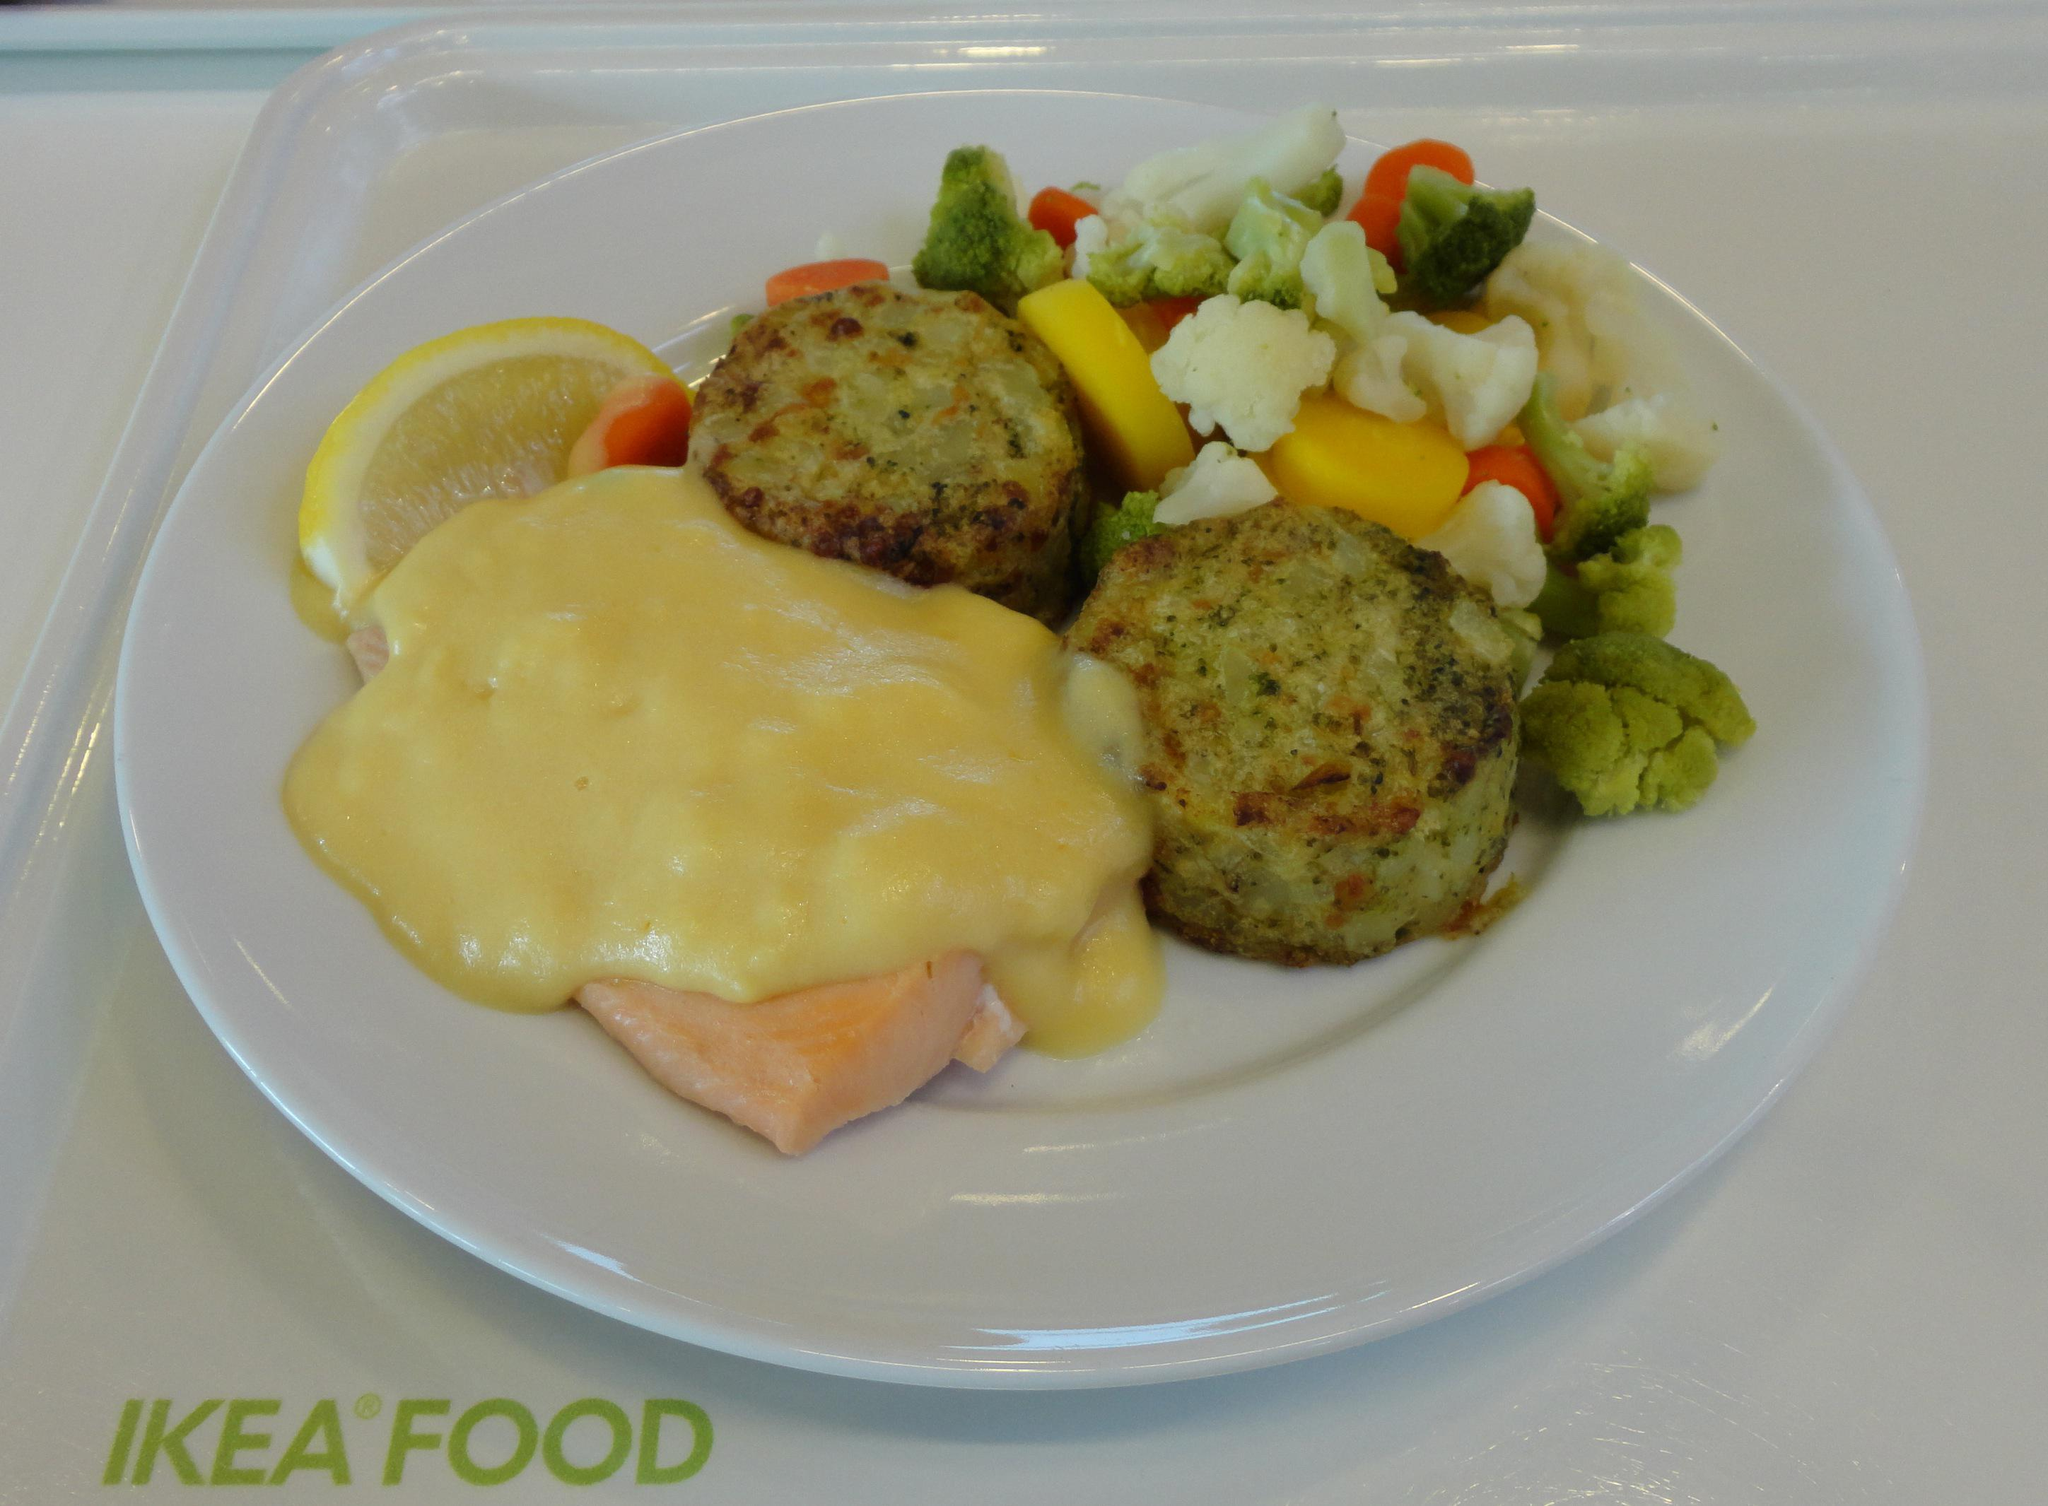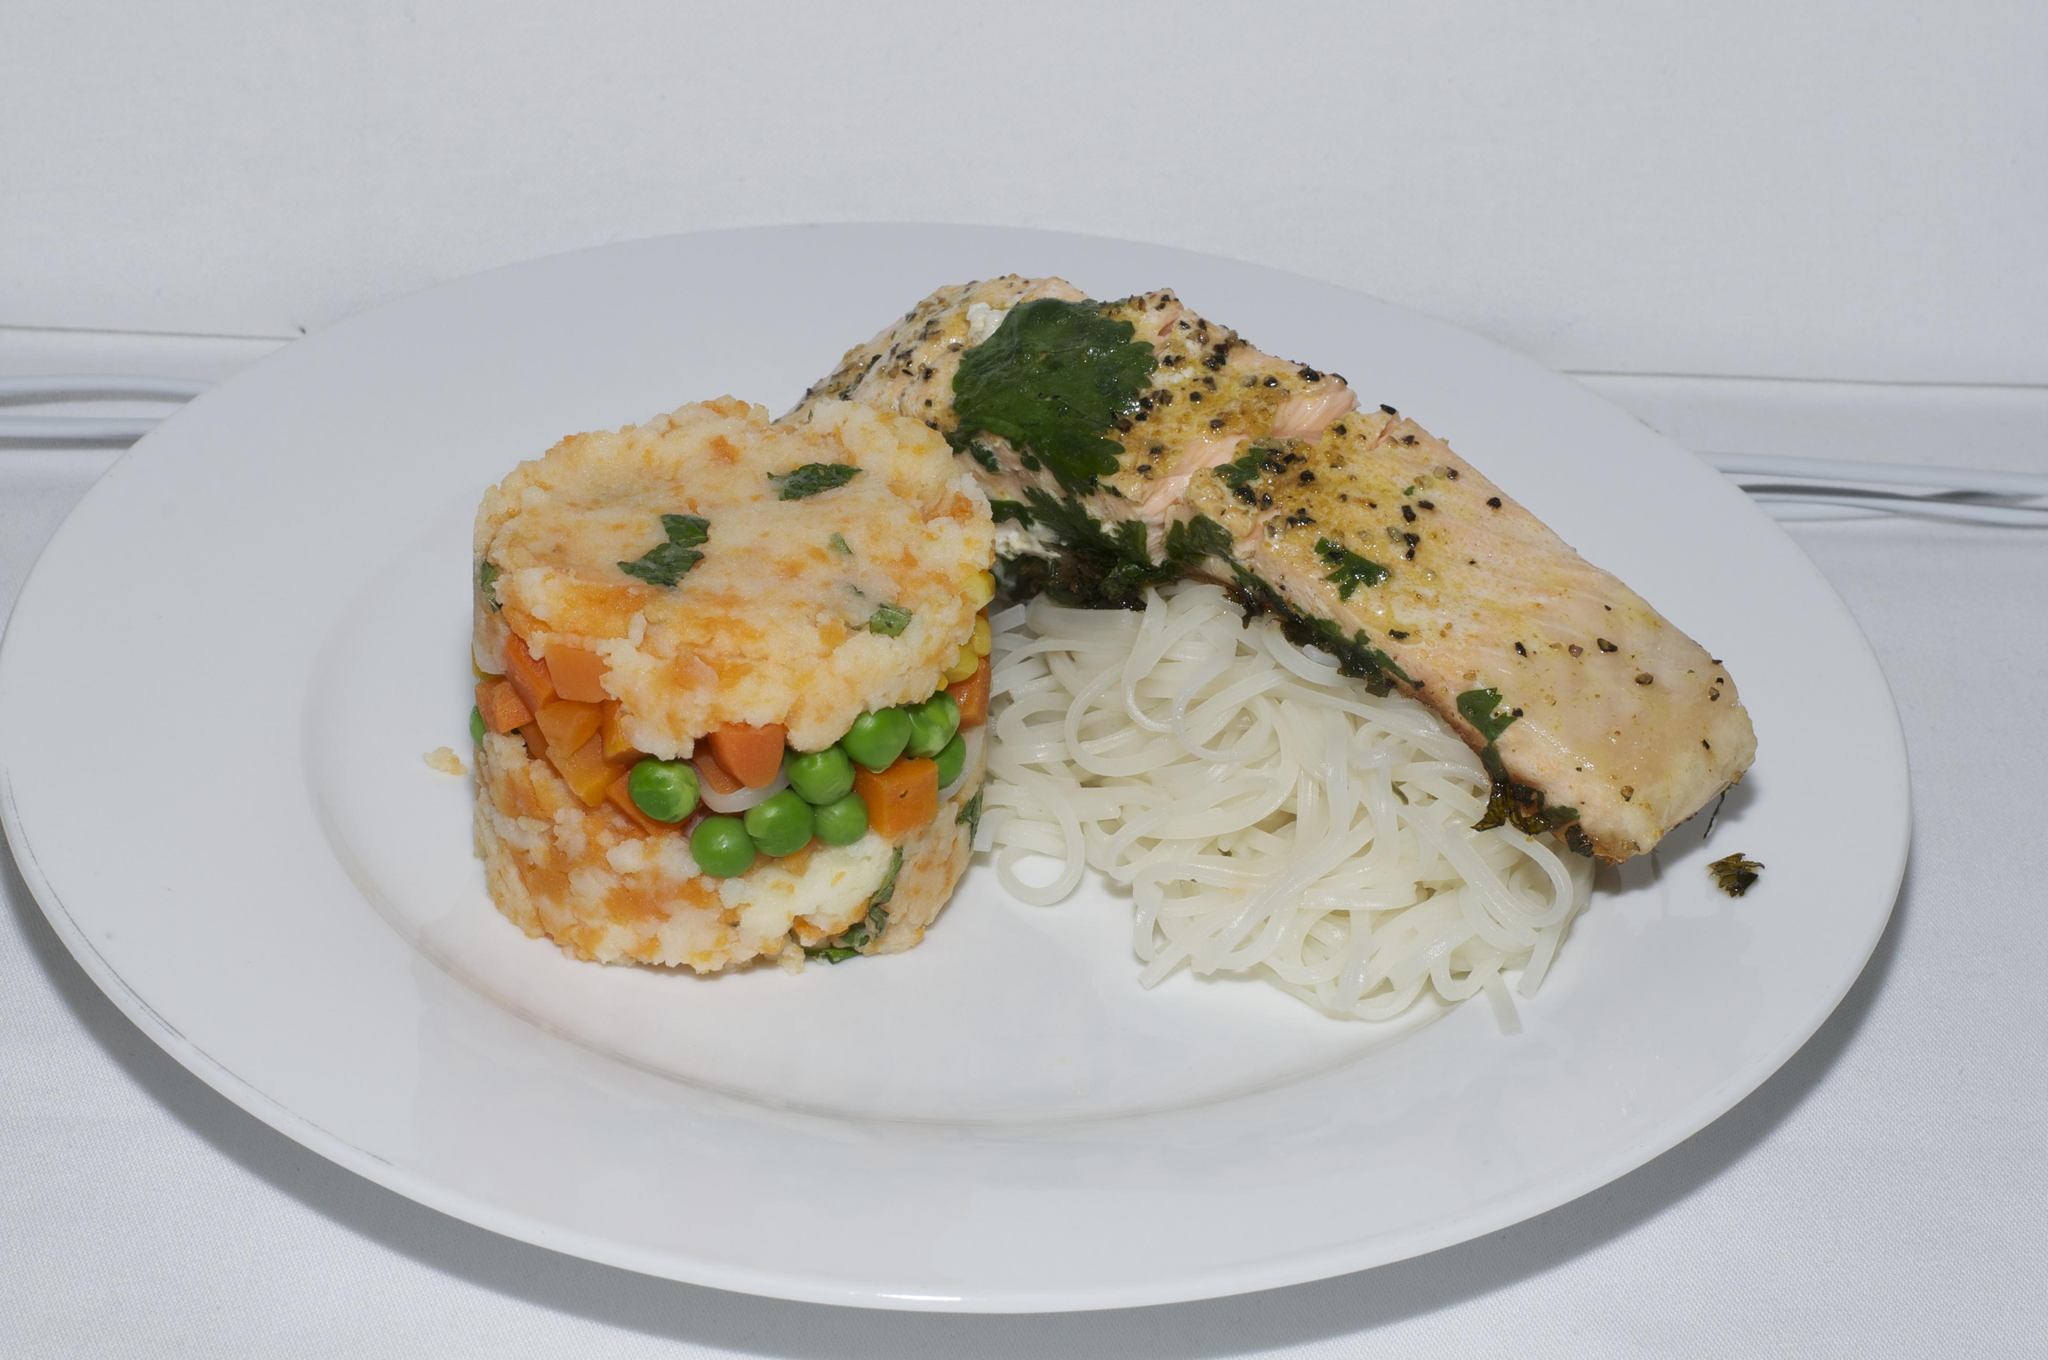The first image is the image on the left, the second image is the image on the right. Examine the images to the left and right. Is the description "One image shows a vertical stack of at least four 'solid' food items including similar items, and the other image shows a base food item with some other food item on top of it." accurate? Answer yes or no. No. 